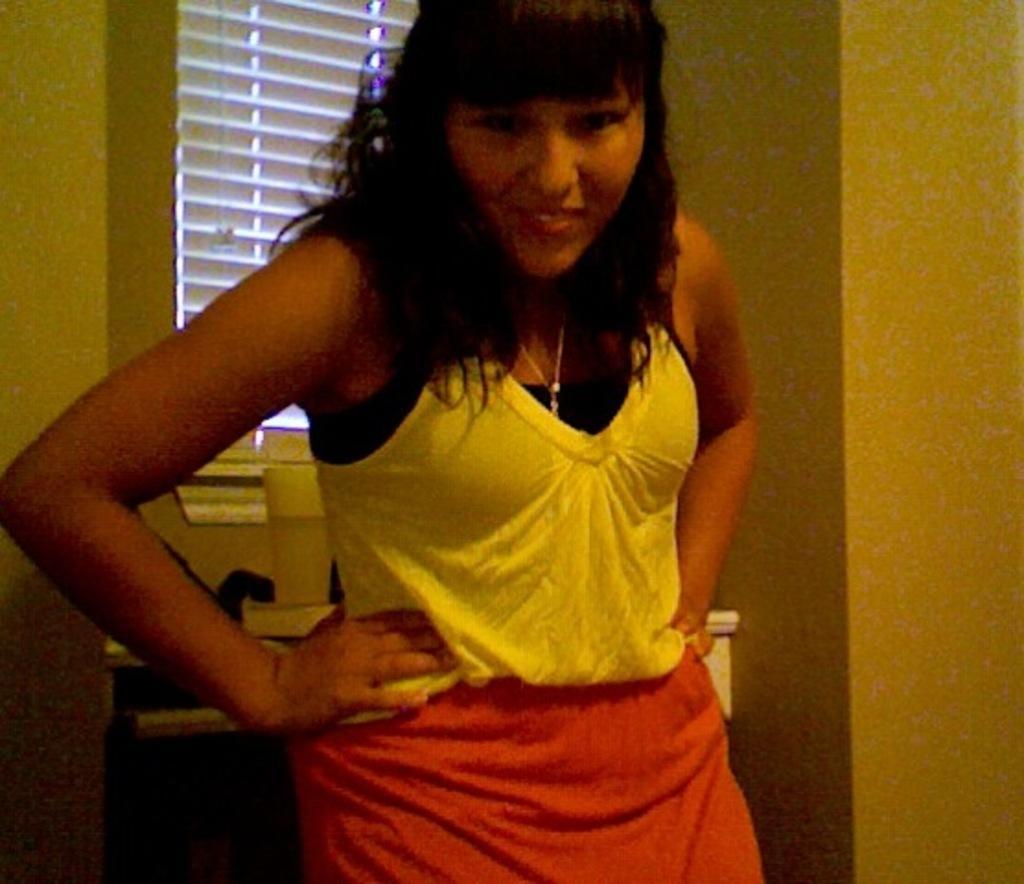How would you summarize this image in a sentence or two? Here we can see a woman is standing. In-front of this window there is a glass. 